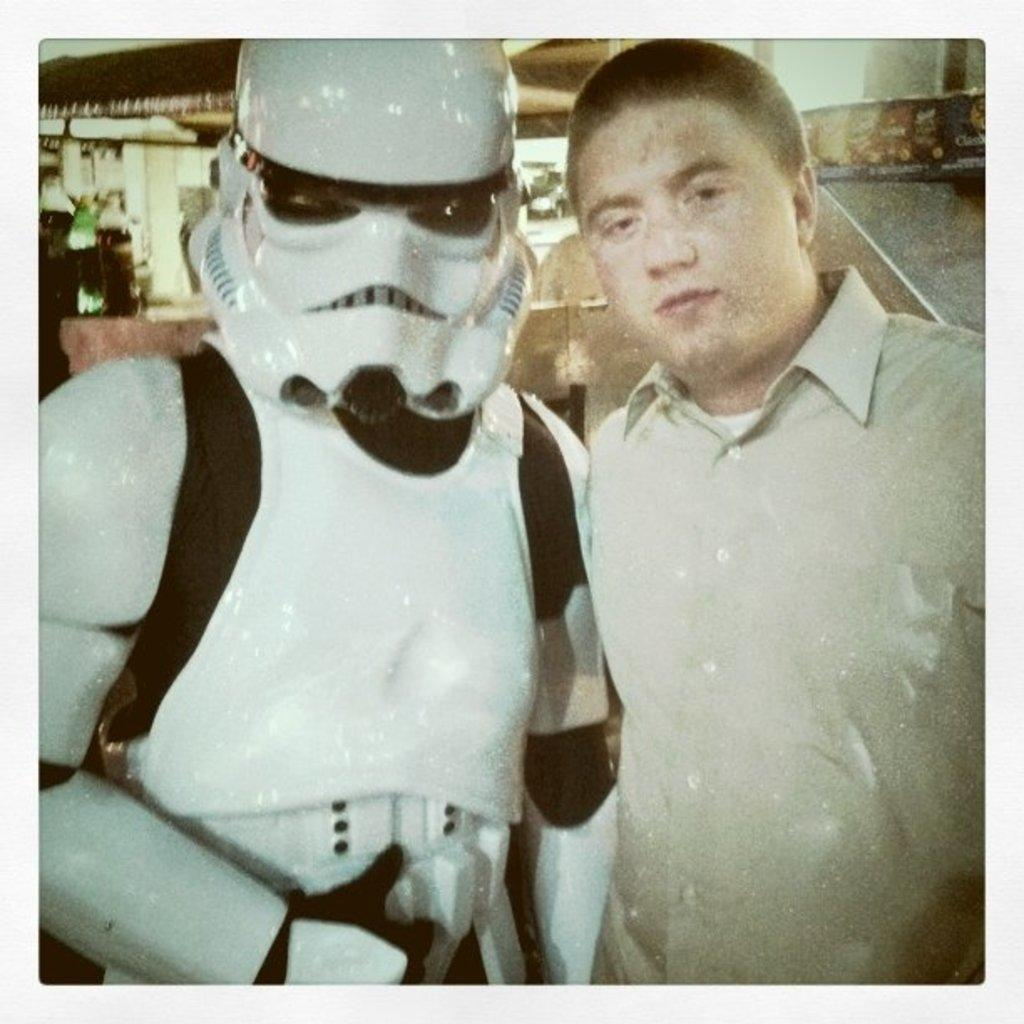What is the person in the image doing? The person is taking a snap in the image. What is the person wearing in the image? The person is wearing a white T-shirt in the image. What other subject is present in the image? There is a robot in the image. What color is the robot in the image? The robot is white in color. What can be seen in the background of the image? There is a wall and lights visible in the background of the image. Can you tell me how many pictures are hanging on the edge of the wall in the image? There is no mention of pictures hanging on the edge of the wall in the image. 